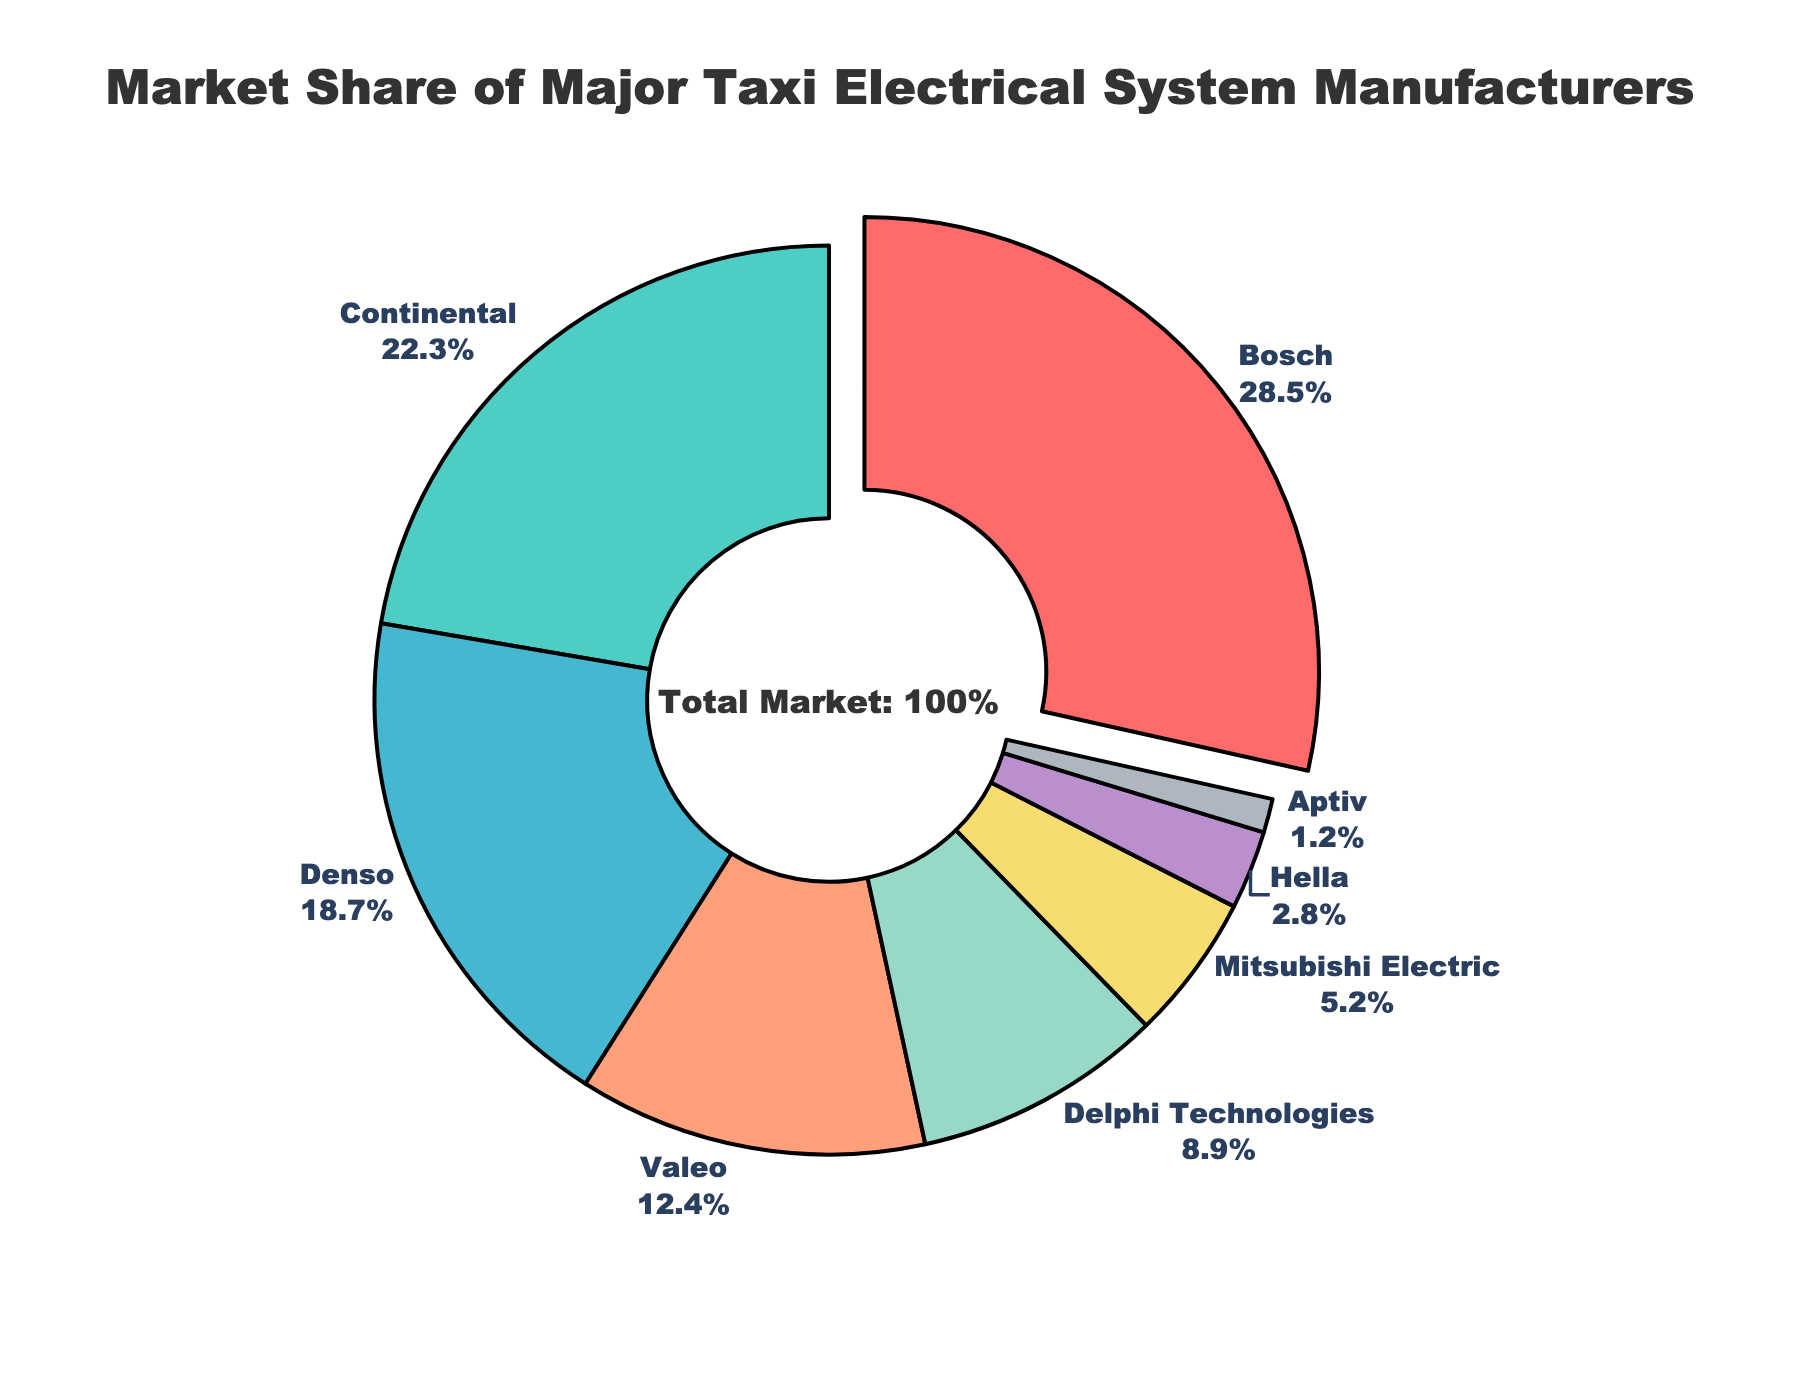What is the market share of Bosch? By observing the figure, look for the segment labeled "Bosch" and note its market share percentage.
Answer: 28.5% Which manufacturer has the smallest market share? Look at the figure and identify the segment with the smallest size, labeled "Aptiv".
Answer: Aptiv How much more market share does Bosch have compared to Continental? Subtract the market share of Continental from that of Bosch: 28.5% - 22.3%.
Answer: 6.2% What is the combined market share of Denso and Valeo? Add the market shares of Denso and Valeo: 18.7% + 12.4%.
Answer: 31.1% Which manufacturer is represented by the darkest green color? The visual segment with the darkest green color is labeled "Continental".
Answer: Continental Compare the market shares of Mitsubishi Electric and Delphi Technologies. Look at the figure and compare the segments labeled "Mitsubishi Electric" (5.2%) and "Delphi Technologies" (8.9%). Mitsubishi Electric has a smaller market share.
Answer: Mitsubishi Electric < Delphi Technologies What is the total market share of manufacturers with less than 10% each? Add the market shares of Valeo, Delphi Technologies, Mitsubishi Electric, Hella, and Aptiv: 12.4% + 8.9% + 5.2% + 2.8% + 1.2%.
Answer: 30.5% Which manufacturer has the largest market share and is pulled from the center? The figure highlights the segment with the largest market share, Bosch, by pulling it out from the center.
Answer: Bosch 